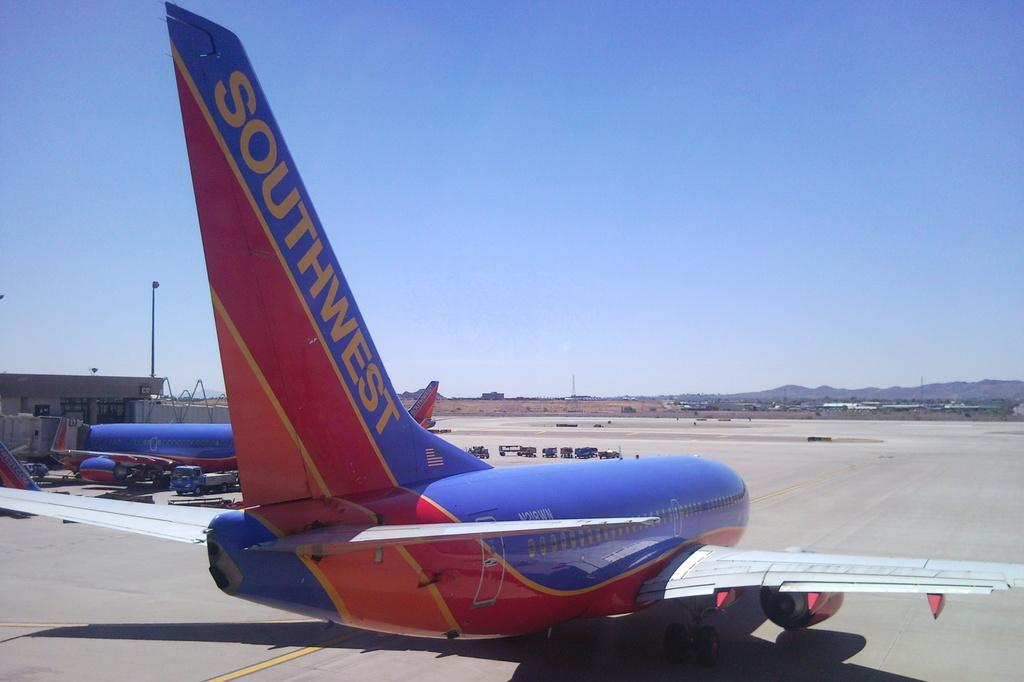Provide a one-sentence caption for the provided image. Airplane that is southwest is landed on the ground. 